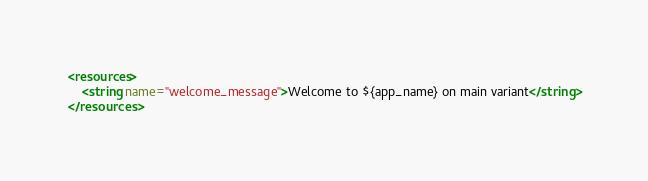<code> <loc_0><loc_0><loc_500><loc_500><_XML_><resources>
    <string name="welcome_message">Welcome to ${app_name} on main variant</string>
</resources></code> 